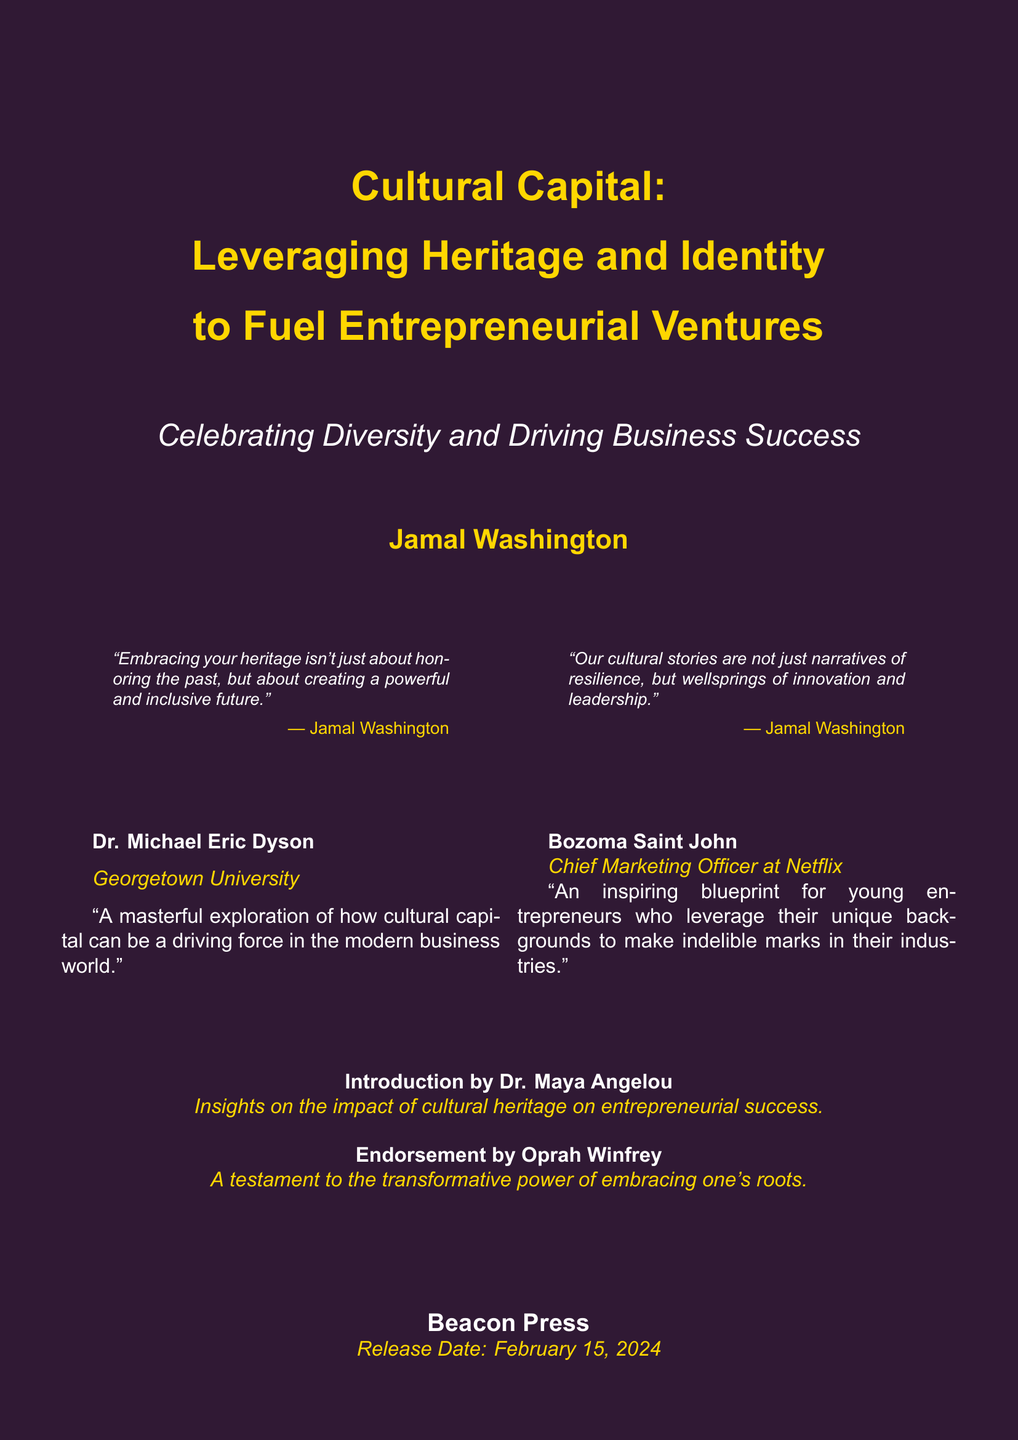What is the title of the book? The title of the book is prominently displayed at the top of the cover, which is "Cultural Capital: Leveraging Heritage and Identity to Fuel Entrepreneurial Ventures."
Answer: Cultural Capital: Leveraging Heritage and Identity to Fuel Entrepreneurial Ventures Who is the author of the book? The author's name is presented below the titles, indicating the person who wrote the book.
Answer: Jamal Washington What is the release date of the book? The release date is located at the bottom of the cover, indicating when the book will be available.
Answer: February 15, 2024 What organization published the book? The publishing organization is noted at the bottom of the cover, indicating where the book will be released from.
Answer: Beacon Press Who provided the introduction to the book? The introduction is credited to a well-known figure in literature, mentioned on the cover.
Answer: Dr. Maya Angelou What is the main theme of the book as indicated by the subtitle? The subtitle, positioned under the main title, highlights the focus of the book on diversity in entrepreneurship.
Answer: Celebrating Diversity and Driving Business Success Which notable personality endorsed the book suggesting its impact? This endorsement comes from a well-known media figure, enhancing the book's credibility.
Answer: Oprah Winfrey What is the color theme of the book cover? The book cover prominently features two main colors that create a visual impact.
Answer: Deep Purple and African Gold 